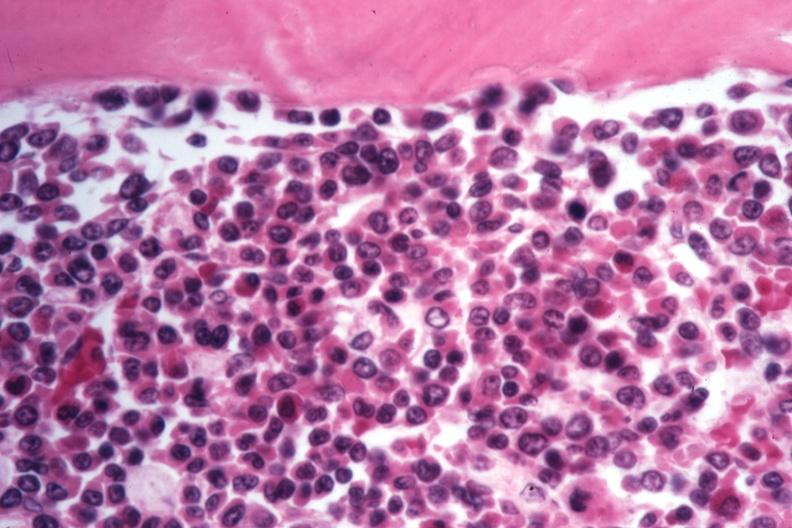s chronic myelogenous leukemia present?
Answer the question using a single word or phrase. Yes 